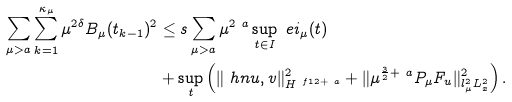<formula> <loc_0><loc_0><loc_500><loc_500>\sum _ { \mu > \L a } \sum _ { k = 1 } ^ { \kappa _ { \mu } } \mu ^ { 2 \delta } B _ { \mu } ( t _ { k - 1 } ) ^ { 2 } & \leq s \sum _ { \mu > \L a } \mu ^ { 2 \ a } \sup _ { t \in I } \ e i _ { \mu } ( t ) \\ & + \sup _ { t } \left ( \| \ h n u , v \| _ { H ^ { \ f 1 2 + \ a } } ^ { 2 } + \| \mu ^ { \frac { 3 } { 2 } + \ a } P _ { \mu } F _ { u } \| _ { l _ { \mu } ^ { 2 } L _ { x } ^ { 2 } } ^ { 2 } \right ) .</formula> 